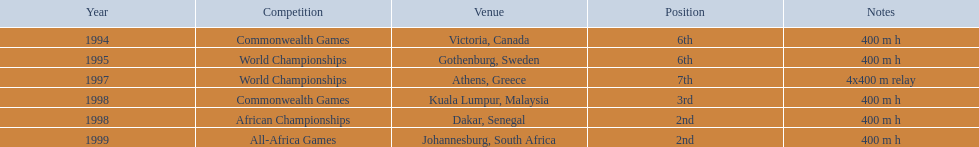In which nation were the 1997 championships conducted? Athens, Greece. How lengthy was the relay? 4x400 m relay. 